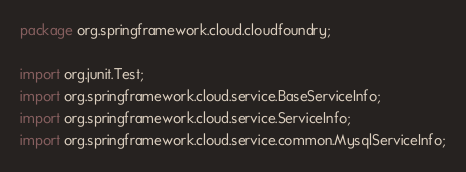<code> <loc_0><loc_0><loc_500><loc_500><_Java_>package org.springframework.cloud.cloudfoundry;

import org.junit.Test;
import org.springframework.cloud.service.BaseServiceInfo;
import org.springframework.cloud.service.ServiceInfo;
import org.springframework.cloud.service.common.MysqlServiceInfo;</code> 